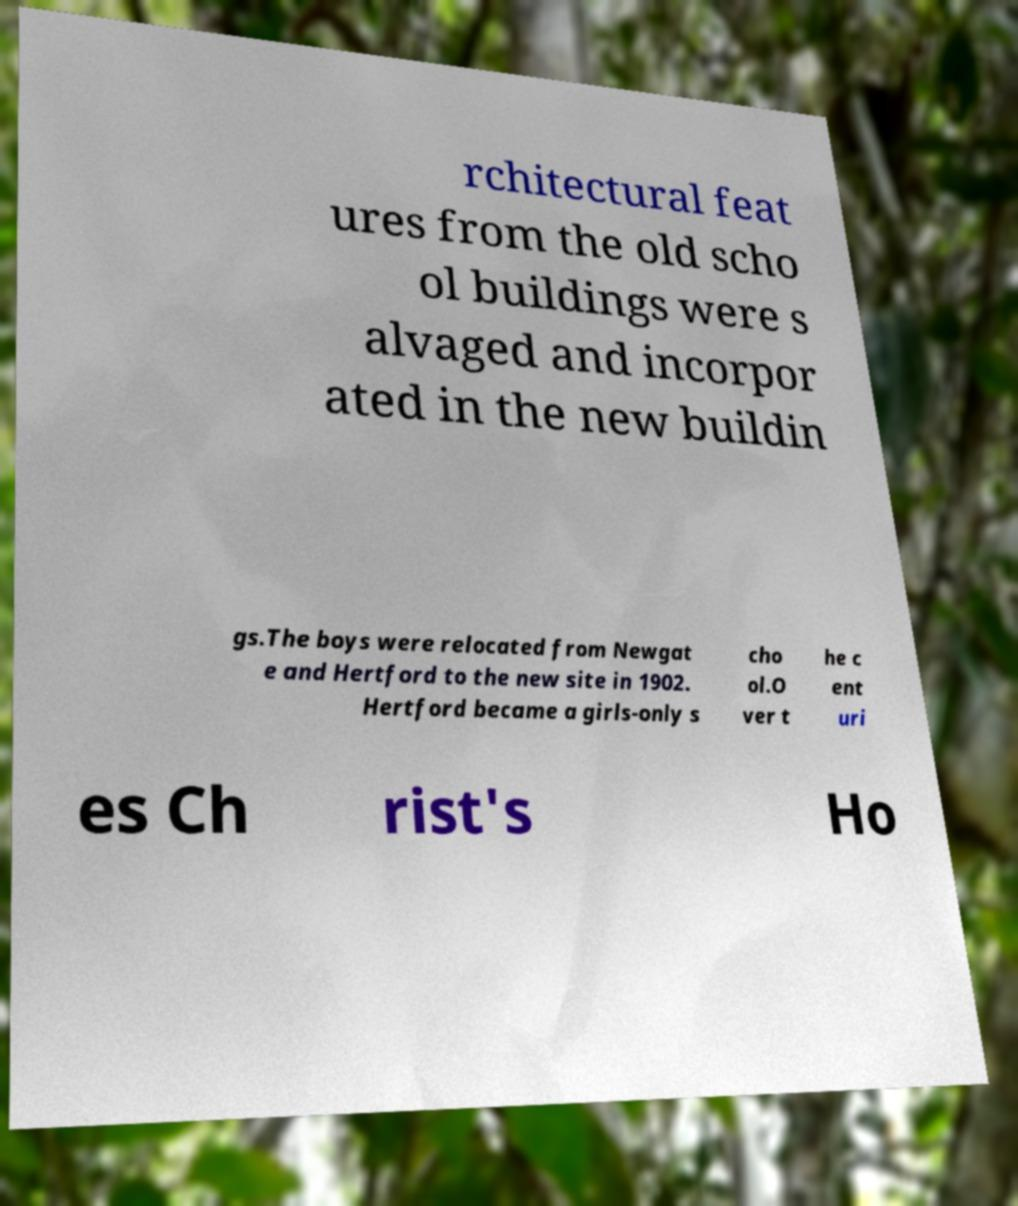Can you accurately transcribe the text from the provided image for me? rchitectural feat ures from the old scho ol buildings were s alvaged and incorpor ated in the new buildin gs.The boys were relocated from Newgat e and Hertford to the new site in 1902. Hertford became a girls-only s cho ol.O ver t he c ent uri es Ch rist's Ho 